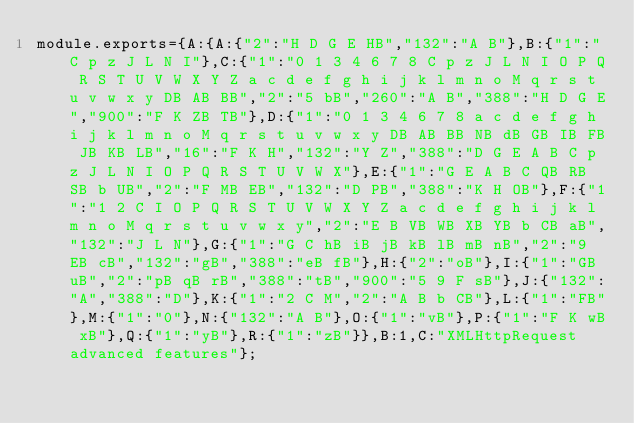Convert code to text. <code><loc_0><loc_0><loc_500><loc_500><_JavaScript_>module.exports={A:{A:{"2":"H D G E HB","132":"A B"},B:{"1":"C p z J L N I"},C:{"1":"0 1 3 4 6 7 8 C p z J L N I O P Q R S T U V W X Y Z a c d e f g h i j k l m n o M q r s t u v w x y DB AB BB","2":"5 bB","260":"A B","388":"H D G E","900":"F K ZB TB"},D:{"1":"0 1 3 4 6 7 8 a c d e f g h i j k l m n o M q r s t u v w x y DB AB BB NB dB GB IB FB JB KB LB","16":"F K H","132":"Y Z","388":"D G E A B C p z J L N I O P Q R S T U V W X"},E:{"1":"G E A B C QB RB SB b UB","2":"F MB EB","132":"D PB","388":"K H OB"},F:{"1":"1 2 C I O P Q R S T U V W X Y Z a c d e f g h i j k l m n o M q r s t u v w x y","2":"E B VB WB XB YB b CB aB","132":"J L N"},G:{"1":"G C hB iB jB kB lB mB nB","2":"9 EB cB","132":"gB","388":"eB fB"},H:{"2":"oB"},I:{"1":"GB uB","2":"pB qB rB","388":"tB","900":"5 9 F sB"},J:{"132":"A","388":"D"},K:{"1":"2 C M","2":"A B b CB"},L:{"1":"FB"},M:{"1":"0"},N:{"132":"A B"},O:{"1":"vB"},P:{"1":"F K wB xB"},Q:{"1":"yB"},R:{"1":"zB"}},B:1,C:"XMLHttpRequest advanced features"};
</code> 